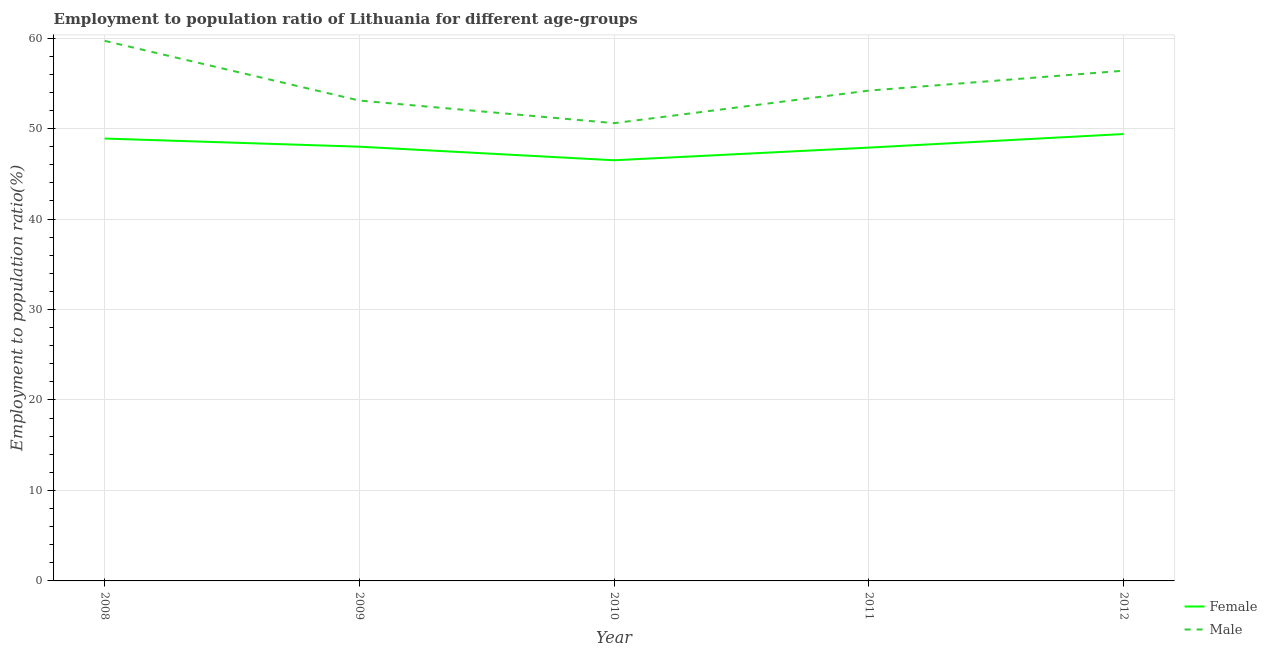What is the employment to population ratio(male) in 2008?
Your answer should be very brief. 59.7. Across all years, what is the maximum employment to population ratio(male)?
Ensure brevity in your answer.  59.7. Across all years, what is the minimum employment to population ratio(female)?
Offer a very short reply. 46.5. In which year was the employment to population ratio(female) minimum?
Provide a short and direct response. 2010. What is the total employment to population ratio(male) in the graph?
Offer a terse response. 274. What is the difference between the employment to population ratio(male) in 2009 and that in 2012?
Offer a terse response. -3.3. What is the difference between the employment to population ratio(female) in 2011 and the employment to population ratio(male) in 2009?
Your answer should be compact. -5.2. What is the average employment to population ratio(male) per year?
Your answer should be very brief. 54.8. In the year 2009, what is the difference between the employment to population ratio(male) and employment to population ratio(female)?
Provide a short and direct response. 5.1. In how many years, is the employment to population ratio(male) greater than 12 %?
Offer a very short reply. 5. What is the ratio of the employment to population ratio(male) in 2010 to that in 2012?
Your answer should be very brief. 0.9. What is the difference between the highest and the second highest employment to population ratio(male)?
Make the answer very short. 3.3. What is the difference between the highest and the lowest employment to population ratio(female)?
Your answer should be very brief. 2.9. Is the employment to population ratio(male) strictly less than the employment to population ratio(female) over the years?
Your answer should be very brief. No. How many years are there in the graph?
Offer a terse response. 5. What is the difference between two consecutive major ticks on the Y-axis?
Provide a short and direct response. 10. Are the values on the major ticks of Y-axis written in scientific E-notation?
Keep it short and to the point. No. Does the graph contain grids?
Ensure brevity in your answer.  Yes. Where does the legend appear in the graph?
Your response must be concise. Bottom right. How are the legend labels stacked?
Provide a short and direct response. Vertical. What is the title of the graph?
Give a very brief answer. Employment to population ratio of Lithuania for different age-groups. Does "Male labourers" appear as one of the legend labels in the graph?
Provide a succinct answer. No. What is the label or title of the X-axis?
Provide a short and direct response. Year. What is the label or title of the Y-axis?
Make the answer very short. Employment to population ratio(%). What is the Employment to population ratio(%) of Female in 2008?
Make the answer very short. 48.9. What is the Employment to population ratio(%) in Male in 2008?
Provide a succinct answer. 59.7. What is the Employment to population ratio(%) in Female in 2009?
Offer a terse response. 48. What is the Employment to population ratio(%) in Male in 2009?
Offer a very short reply. 53.1. What is the Employment to population ratio(%) in Female in 2010?
Provide a short and direct response. 46.5. What is the Employment to population ratio(%) in Male in 2010?
Your response must be concise. 50.6. What is the Employment to population ratio(%) in Female in 2011?
Offer a terse response. 47.9. What is the Employment to population ratio(%) in Male in 2011?
Offer a terse response. 54.2. What is the Employment to population ratio(%) of Female in 2012?
Your answer should be compact. 49.4. What is the Employment to population ratio(%) in Male in 2012?
Your answer should be compact. 56.4. Across all years, what is the maximum Employment to population ratio(%) of Female?
Provide a succinct answer. 49.4. Across all years, what is the maximum Employment to population ratio(%) of Male?
Give a very brief answer. 59.7. Across all years, what is the minimum Employment to population ratio(%) of Female?
Your answer should be very brief. 46.5. Across all years, what is the minimum Employment to population ratio(%) of Male?
Your answer should be very brief. 50.6. What is the total Employment to population ratio(%) of Female in the graph?
Ensure brevity in your answer.  240.7. What is the total Employment to population ratio(%) of Male in the graph?
Offer a very short reply. 274. What is the difference between the Employment to population ratio(%) of Female in 2008 and that in 2011?
Offer a terse response. 1. What is the difference between the Employment to population ratio(%) of Female in 2008 and that in 2012?
Your answer should be compact. -0.5. What is the difference between the Employment to population ratio(%) of Female in 2009 and that in 2010?
Offer a terse response. 1.5. What is the difference between the Employment to population ratio(%) of Male in 2009 and that in 2010?
Make the answer very short. 2.5. What is the difference between the Employment to population ratio(%) of Female in 2010 and that in 2012?
Your response must be concise. -2.9. What is the difference between the Employment to population ratio(%) of Male in 2010 and that in 2012?
Keep it short and to the point. -5.8. What is the difference between the Employment to population ratio(%) in Male in 2011 and that in 2012?
Provide a succinct answer. -2.2. What is the difference between the Employment to population ratio(%) of Female in 2008 and the Employment to population ratio(%) of Male in 2010?
Your answer should be very brief. -1.7. What is the difference between the Employment to population ratio(%) in Female in 2009 and the Employment to population ratio(%) in Male in 2010?
Provide a succinct answer. -2.6. What is the average Employment to population ratio(%) in Female per year?
Offer a very short reply. 48.14. What is the average Employment to population ratio(%) in Male per year?
Your answer should be compact. 54.8. In the year 2008, what is the difference between the Employment to population ratio(%) of Female and Employment to population ratio(%) of Male?
Keep it short and to the point. -10.8. In the year 2009, what is the difference between the Employment to population ratio(%) in Female and Employment to population ratio(%) in Male?
Your answer should be compact. -5.1. In the year 2010, what is the difference between the Employment to population ratio(%) of Female and Employment to population ratio(%) of Male?
Provide a short and direct response. -4.1. In the year 2011, what is the difference between the Employment to population ratio(%) in Female and Employment to population ratio(%) in Male?
Ensure brevity in your answer.  -6.3. What is the ratio of the Employment to population ratio(%) of Female in 2008 to that in 2009?
Make the answer very short. 1.02. What is the ratio of the Employment to population ratio(%) of Male in 2008 to that in 2009?
Keep it short and to the point. 1.12. What is the ratio of the Employment to population ratio(%) in Female in 2008 to that in 2010?
Your answer should be very brief. 1.05. What is the ratio of the Employment to population ratio(%) in Male in 2008 to that in 2010?
Ensure brevity in your answer.  1.18. What is the ratio of the Employment to population ratio(%) of Female in 2008 to that in 2011?
Give a very brief answer. 1.02. What is the ratio of the Employment to population ratio(%) of Male in 2008 to that in 2011?
Provide a succinct answer. 1.1. What is the ratio of the Employment to population ratio(%) in Male in 2008 to that in 2012?
Offer a very short reply. 1.06. What is the ratio of the Employment to population ratio(%) in Female in 2009 to that in 2010?
Provide a succinct answer. 1.03. What is the ratio of the Employment to population ratio(%) of Male in 2009 to that in 2010?
Give a very brief answer. 1.05. What is the ratio of the Employment to population ratio(%) in Male in 2009 to that in 2011?
Your response must be concise. 0.98. What is the ratio of the Employment to population ratio(%) in Female in 2009 to that in 2012?
Make the answer very short. 0.97. What is the ratio of the Employment to population ratio(%) of Male in 2009 to that in 2012?
Provide a short and direct response. 0.94. What is the ratio of the Employment to population ratio(%) of Female in 2010 to that in 2011?
Provide a succinct answer. 0.97. What is the ratio of the Employment to population ratio(%) in Male in 2010 to that in 2011?
Offer a very short reply. 0.93. What is the ratio of the Employment to population ratio(%) of Female in 2010 to that in 2012?
Provide a succinct answer. 0.94. What is the ratio of the Employment to population ratio(%) of Male in 2010 to that in 2012?
Offer a very short reply. 0.9. What is the ratio of the Employment to population ratio(%) of Female in 2011 to that in 2012?
Your answer should be compact. 0.97. What is the difference between the highest and the second highest Employment to population ratio(%) in Female?
Keep it short and to the point. 0.5. What is the difference between the highest and the second highest Employment to population ratio(%) in Male?
Offer a very short reply. 3.3. 